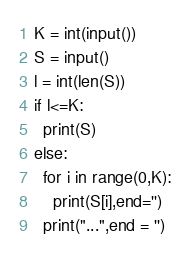<code> <loc_0><loc_0><loc_500><loc_500><_Python_>K = int(input())
S = input()
l = int(len(S))
if l<=K:
  print(S)
else:
  for i in range(0,K):
    print(S[i],end='')
  print("...",end = '')</code> 